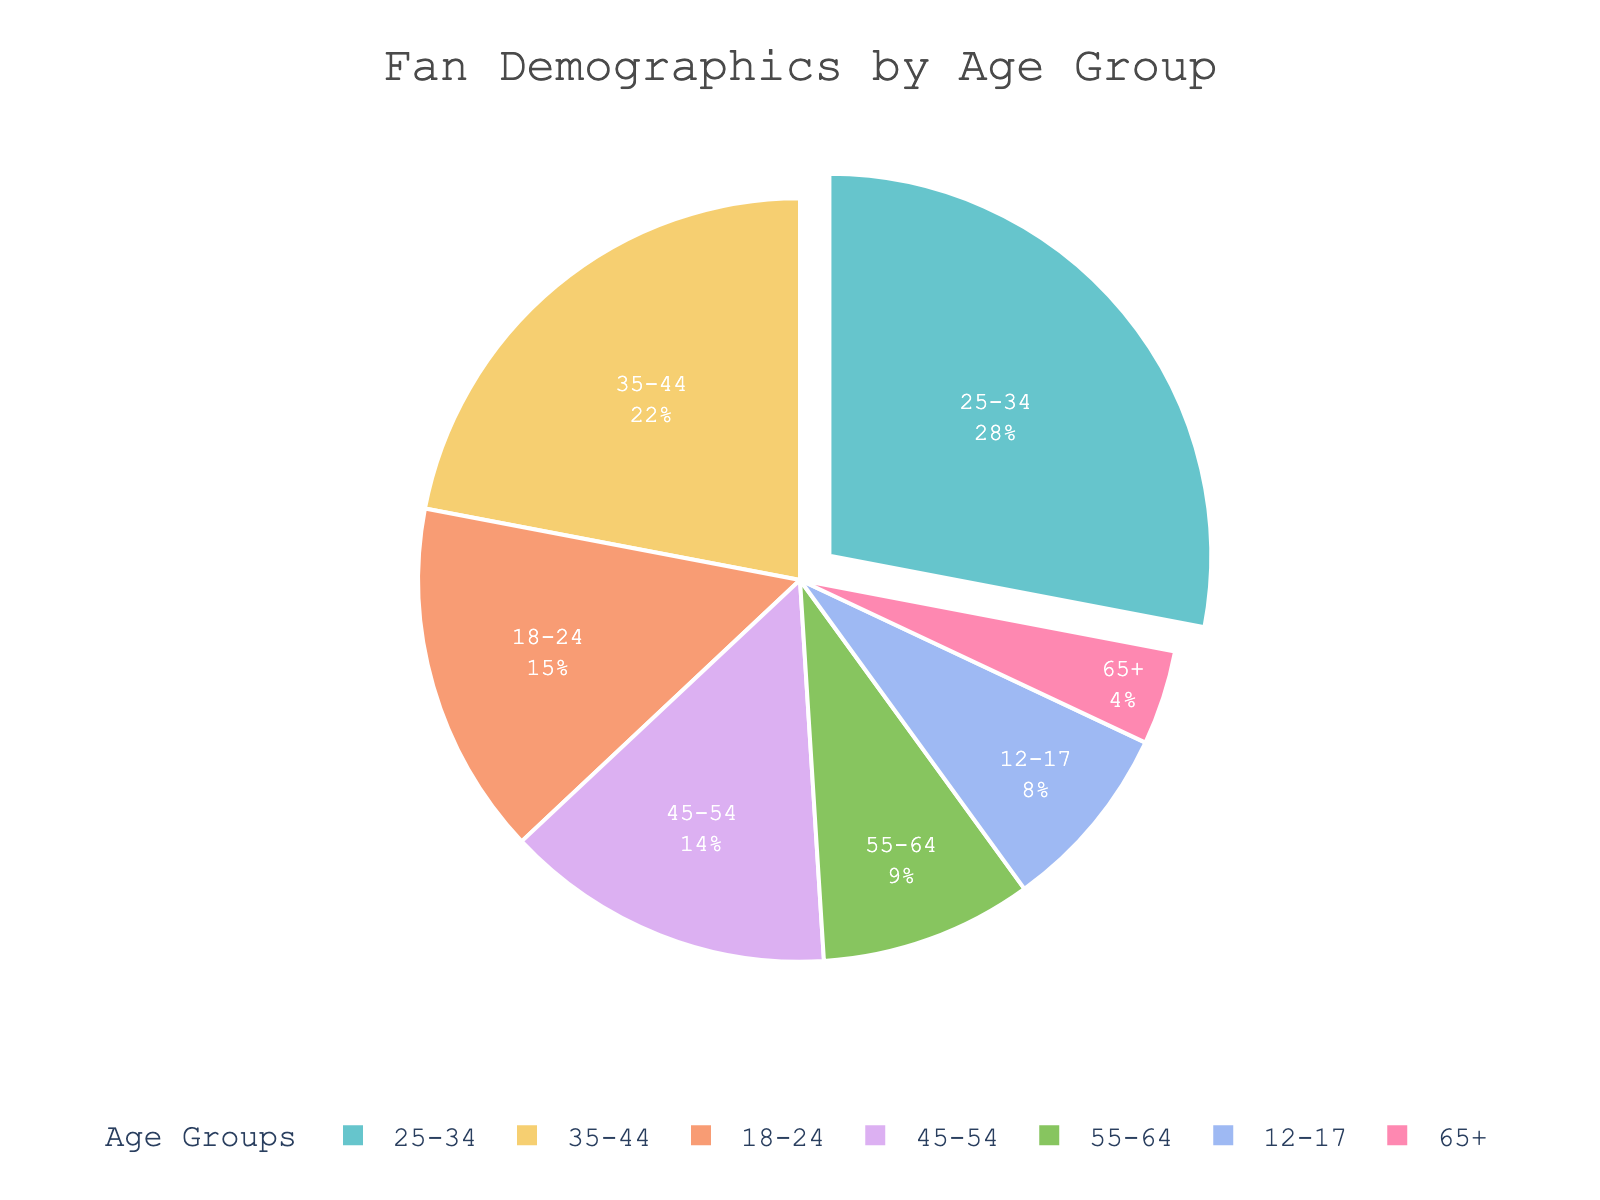What age group has the highest percentage of fans? The pie chart shows the age groups with their respective percentages. The group with the highest percentage is represented with a light blue color and is labeled "25-34" with 28%. Therefore, the age group with the highest percentage of fans is "25-34".
Answer: 25-34 Which age group has the lowest percentage of fans? Observing the pie chart, the slice labeled "65+" has the smallest proportion, with 4%.
Answer: 65+ What is the combined percentage of fans aged 18-24 and 12-17? To find the combined percentage, add the percentages of the 18-24 and 12-17 age groups. 18-24 has 15% and 12-17 has 8%. So, 15% + 8% = 23%.
Answer: 23% How many age groups have a percentage of fans greater than 20%? From the pie chart, identify the age groups with a percentage of more than 20%. The 25-34 age group has 28%, and the 35-44 age group has 22%. So, there are two groups.
Answer: 2 Which is greater, the percentage of fans aged 55-64 or the percentage of fans aged 45-54? Comparing the two age groups, the 55-64 group has 9%, and the 45-54 group has 14%. Therefore, 14% (45-54) is greater than 9% (55-64).
Answer: 45-54 What is the difference in the percentage of fans between the 35-44 and 18-24 age groups? To find the difference, subtract the percentage of the 18-24 group from the 35-44 group. 35-44 has 22% and 18-24 has 15%. So, 22% - 15% = 7%.
Answer: 7% What is the total percentage of fans aged 35-54? Add the percentages of the 35-44 and 45-54 age groups. 35-44 has 22% and 45-54 has 14%. So, 22% + 14% = 36%.
Answer: 36% Which age group is represented by the dark purple section of the pie chart? The pie chart shows the color scheme used for each section. The dark purple section represents the age group 55-64.
Answer: 55-64 Are there more fans aged 12-24 or 55+? Combine the relevant age groups: 12-24 includes the 12-17 and 18-24 groups (8% + 15% = 23%), 55+ includes the 55-64 and 65+ groups (9% + 4% = 13%). 23% (12-24) is greater than 13% (55+).
Answer: 12-24 Which age group's percentage is closest to twice the percentage of fans aged 65+? The percentage of fans aged 65+ is 4%. Twice this amount is 4% * 2 = 8%. The 12-17 age group has 8%, which is exactly twice 4%.
Answer: 12-17 